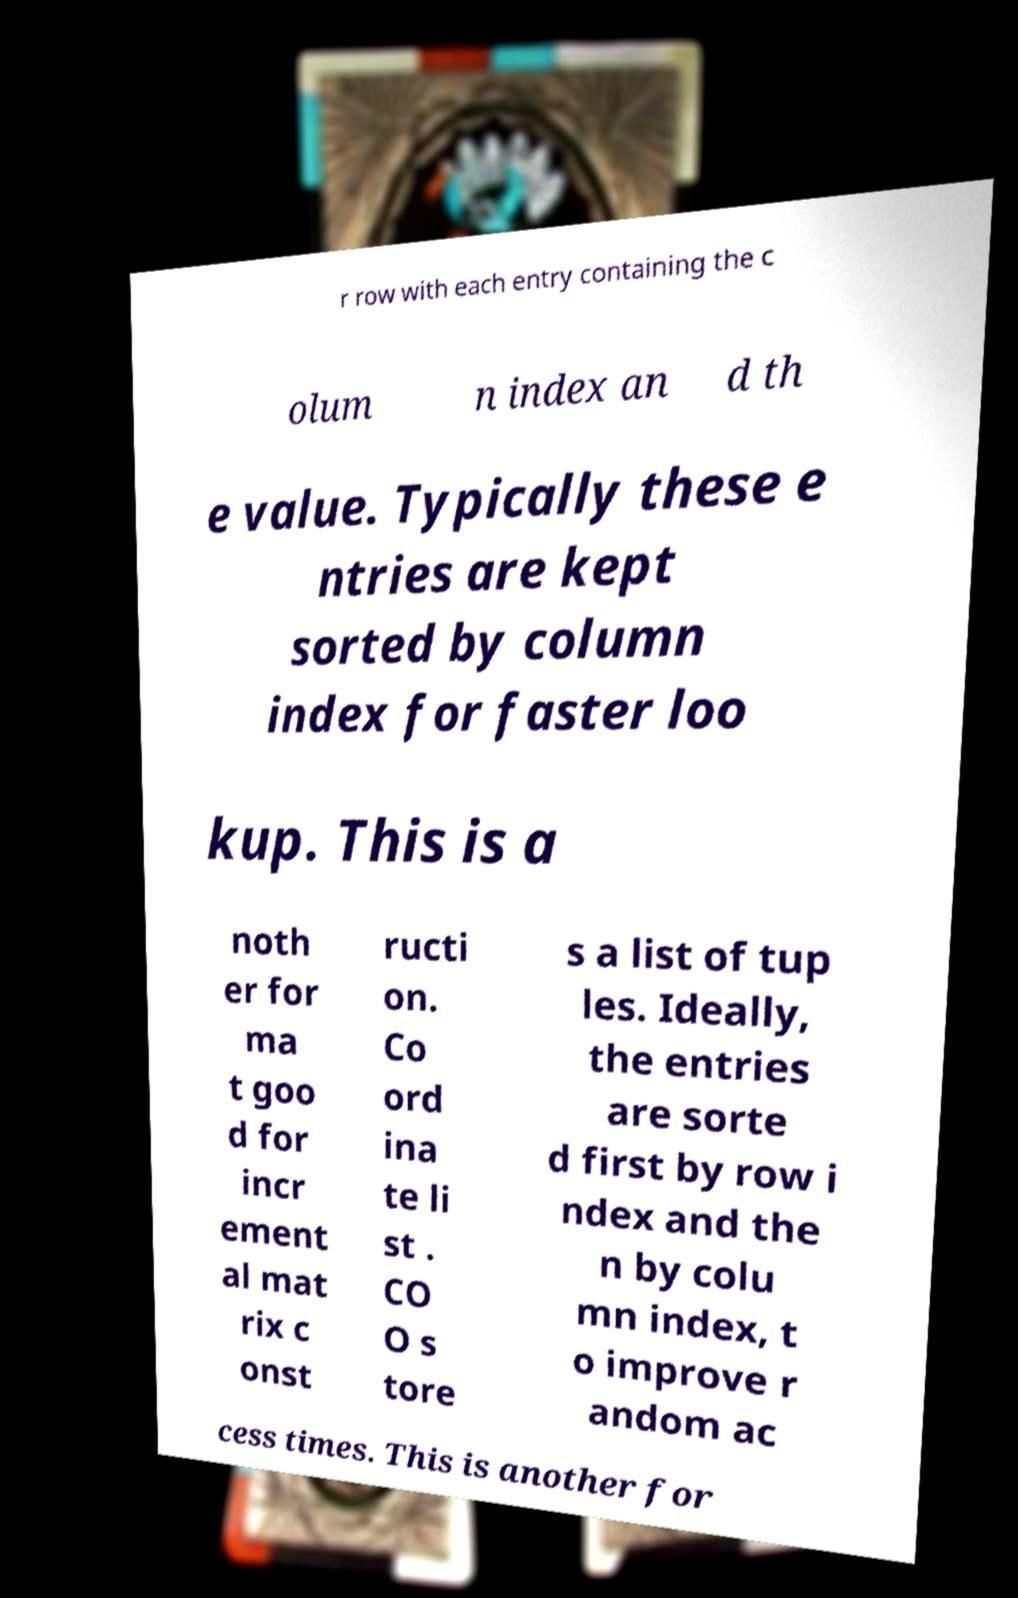I need the written content from this picture converted into text. Can you do that? r row with each entry containing the c olum n index an d th e value. Typically these e ntries are kept sorted by column index for faster loo kup. This is a noth er for ma t goo d for incr ement al mat rix c onst ructi on. Co ord ina te li st . CO O s tore s a list of tup les. Ideally, the entries are sorte d first by row i ndex and the n by colu mn index, t o improve r andom ac cess times. This is another for 